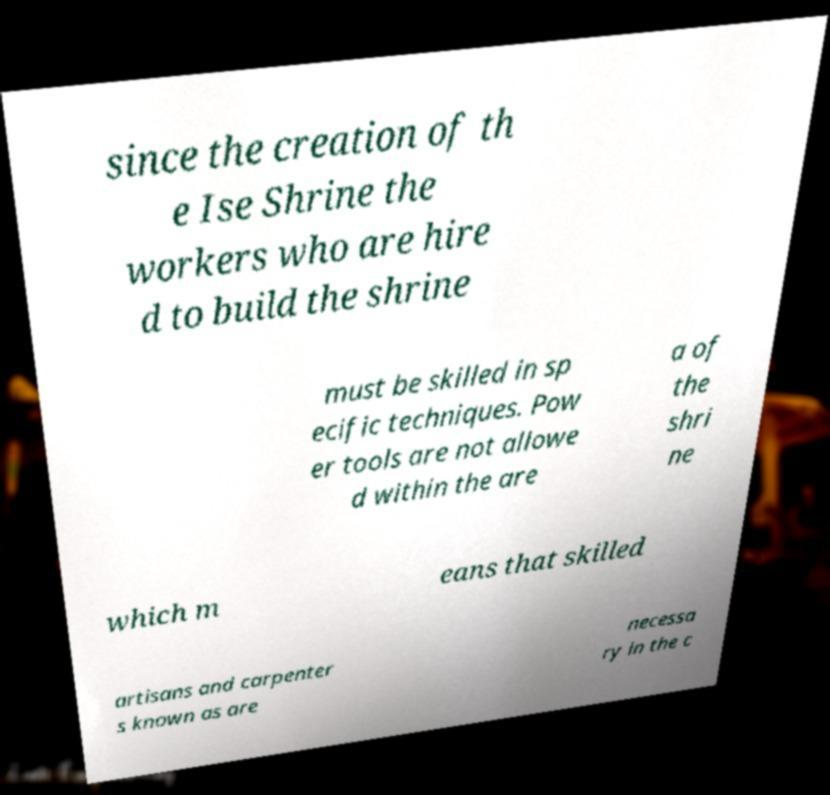Could you extract and type out the text from this image? since the creation of th e Ise Shrine the workers who are hire d to build the shrine must be skilled in sp ecific techniques. Pow er tools are not allowe d within the are a of the shri ne which m eans that skilled artisans and carpenter s known as are necessa ry in the c 